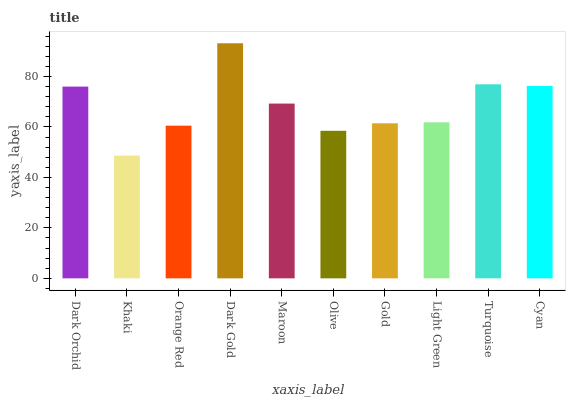Is Khaki the minimum?
Answer yes or no. Yes. Is Dark Gold the maximum?
Answer yes or no. Yes. Is Orange Red the minimum?
Answer yes or no. No. Is Orange Red the maximum?
Answer yes or no. No. Is Orange Red greater than Khaki?
Answer yes or no. Yes. Is Khaki less than Orange Red?
Answer yes or no. Yes. Is Khaki greater than Orange Red?
Answer yes or no. No. Is Orange Red less than Khaki?
Answer yes or no. No. Is Maroon the high median?
Answer yes or no. Yes. Is Light Green the low median?
Answer yes or no. Yes. Is Cyan the high median?
Answer yes or no. No. Is Cyan the low median?
Answer yes or no. No. 